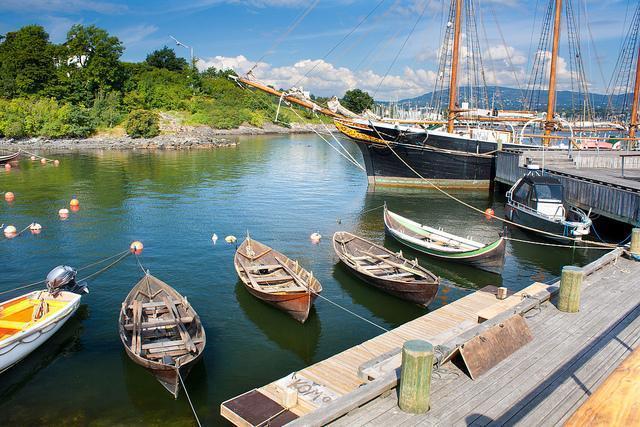How many boats are there?
Give a very brief answer. 7. How many sailboats are there?
Give a very brief answer. 1. How many of the men are wearing a black shirt?
Give a very brief answer. 0. 